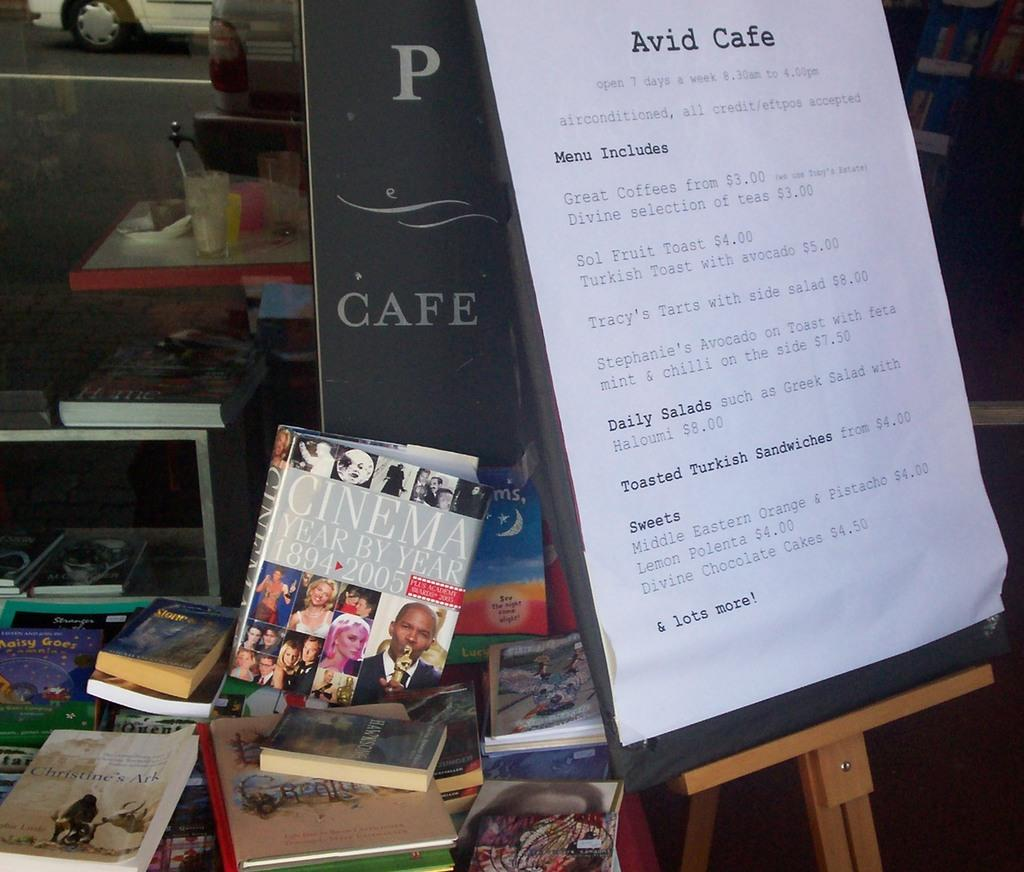<image>
Write a terse but informative summary of the picture. books on a table in front of the Avid Cafe 